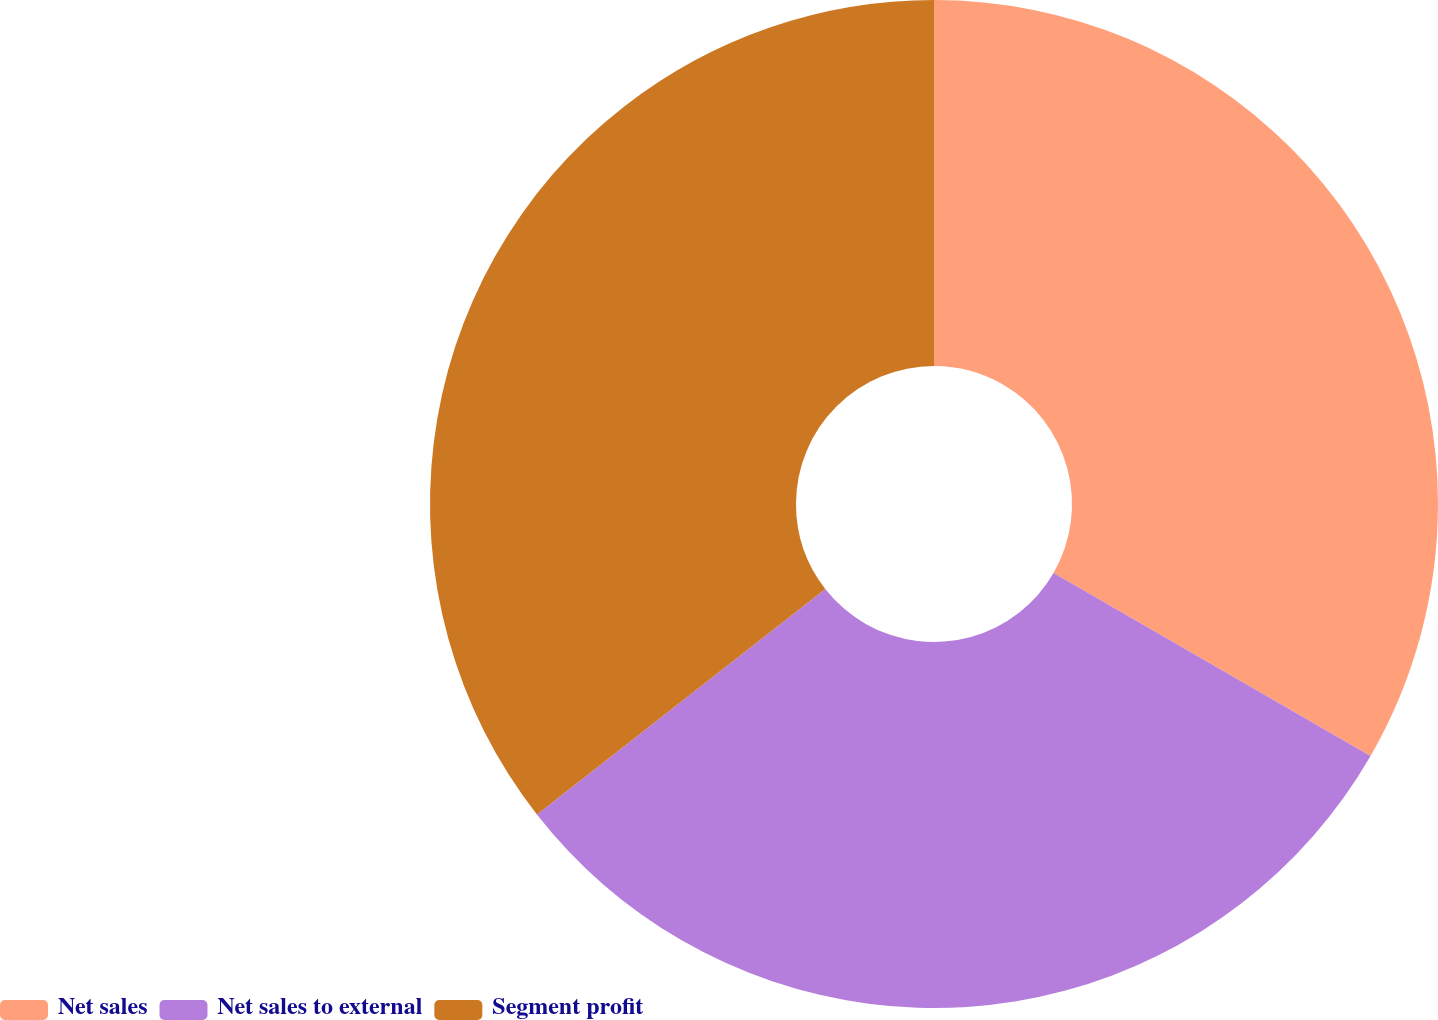<chart> <loc_0><loc_0><loc_500><loc_500><pie_chart><fcel>Net sales<fcel>Net sales to external<fcel>Segment profit<nl><fcel>33.33%<fcel>31.11%<fcel>35.56%<nl></chart> 